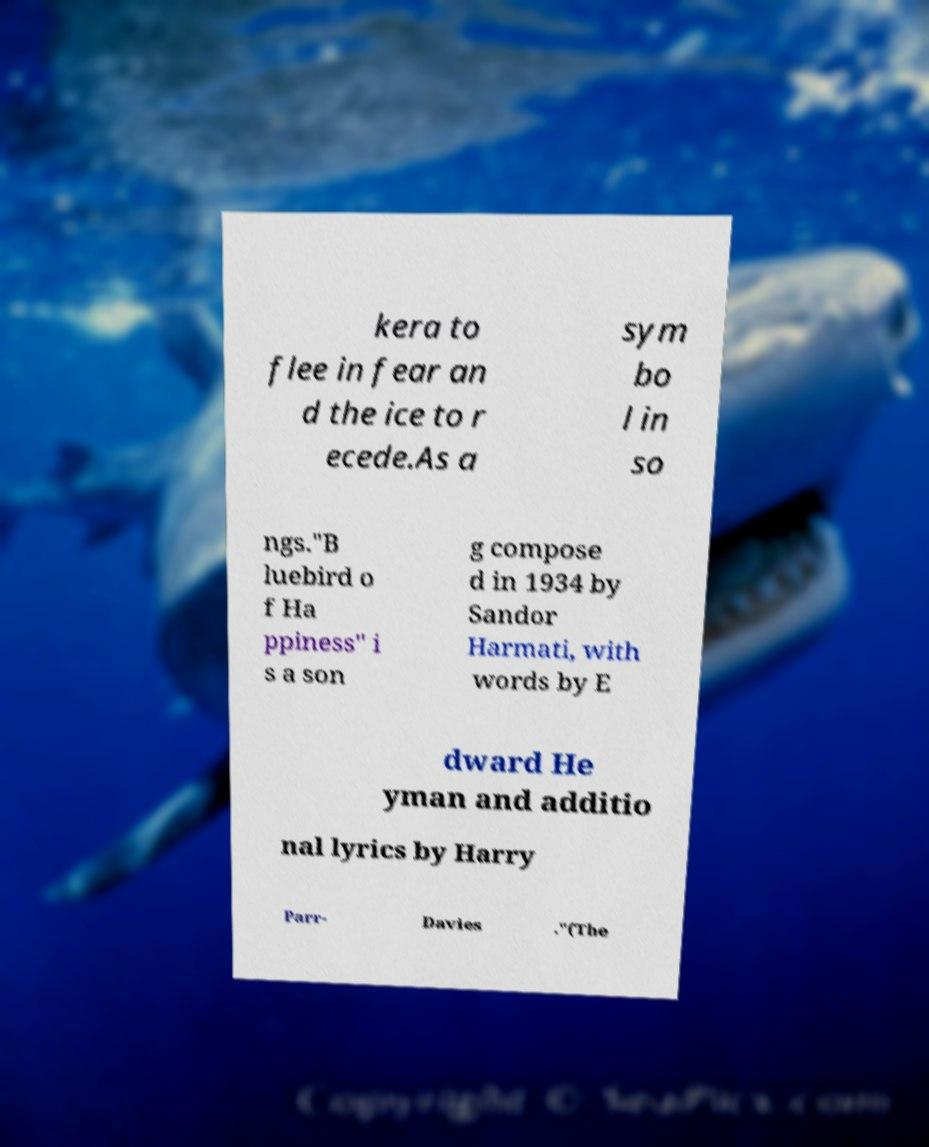For documentation purposes, I need the text within this image transcribed. Could you provide that? kera to flee in fear an d the ice to r ecede.As a sym bo l in so ngs."B luebird o f Ha ppiness" i s a son g compose d in 1934 by Sandor Harmati, with words by E dward He yman and additio nal lyrics by Harry Parr- Davies ."(The 